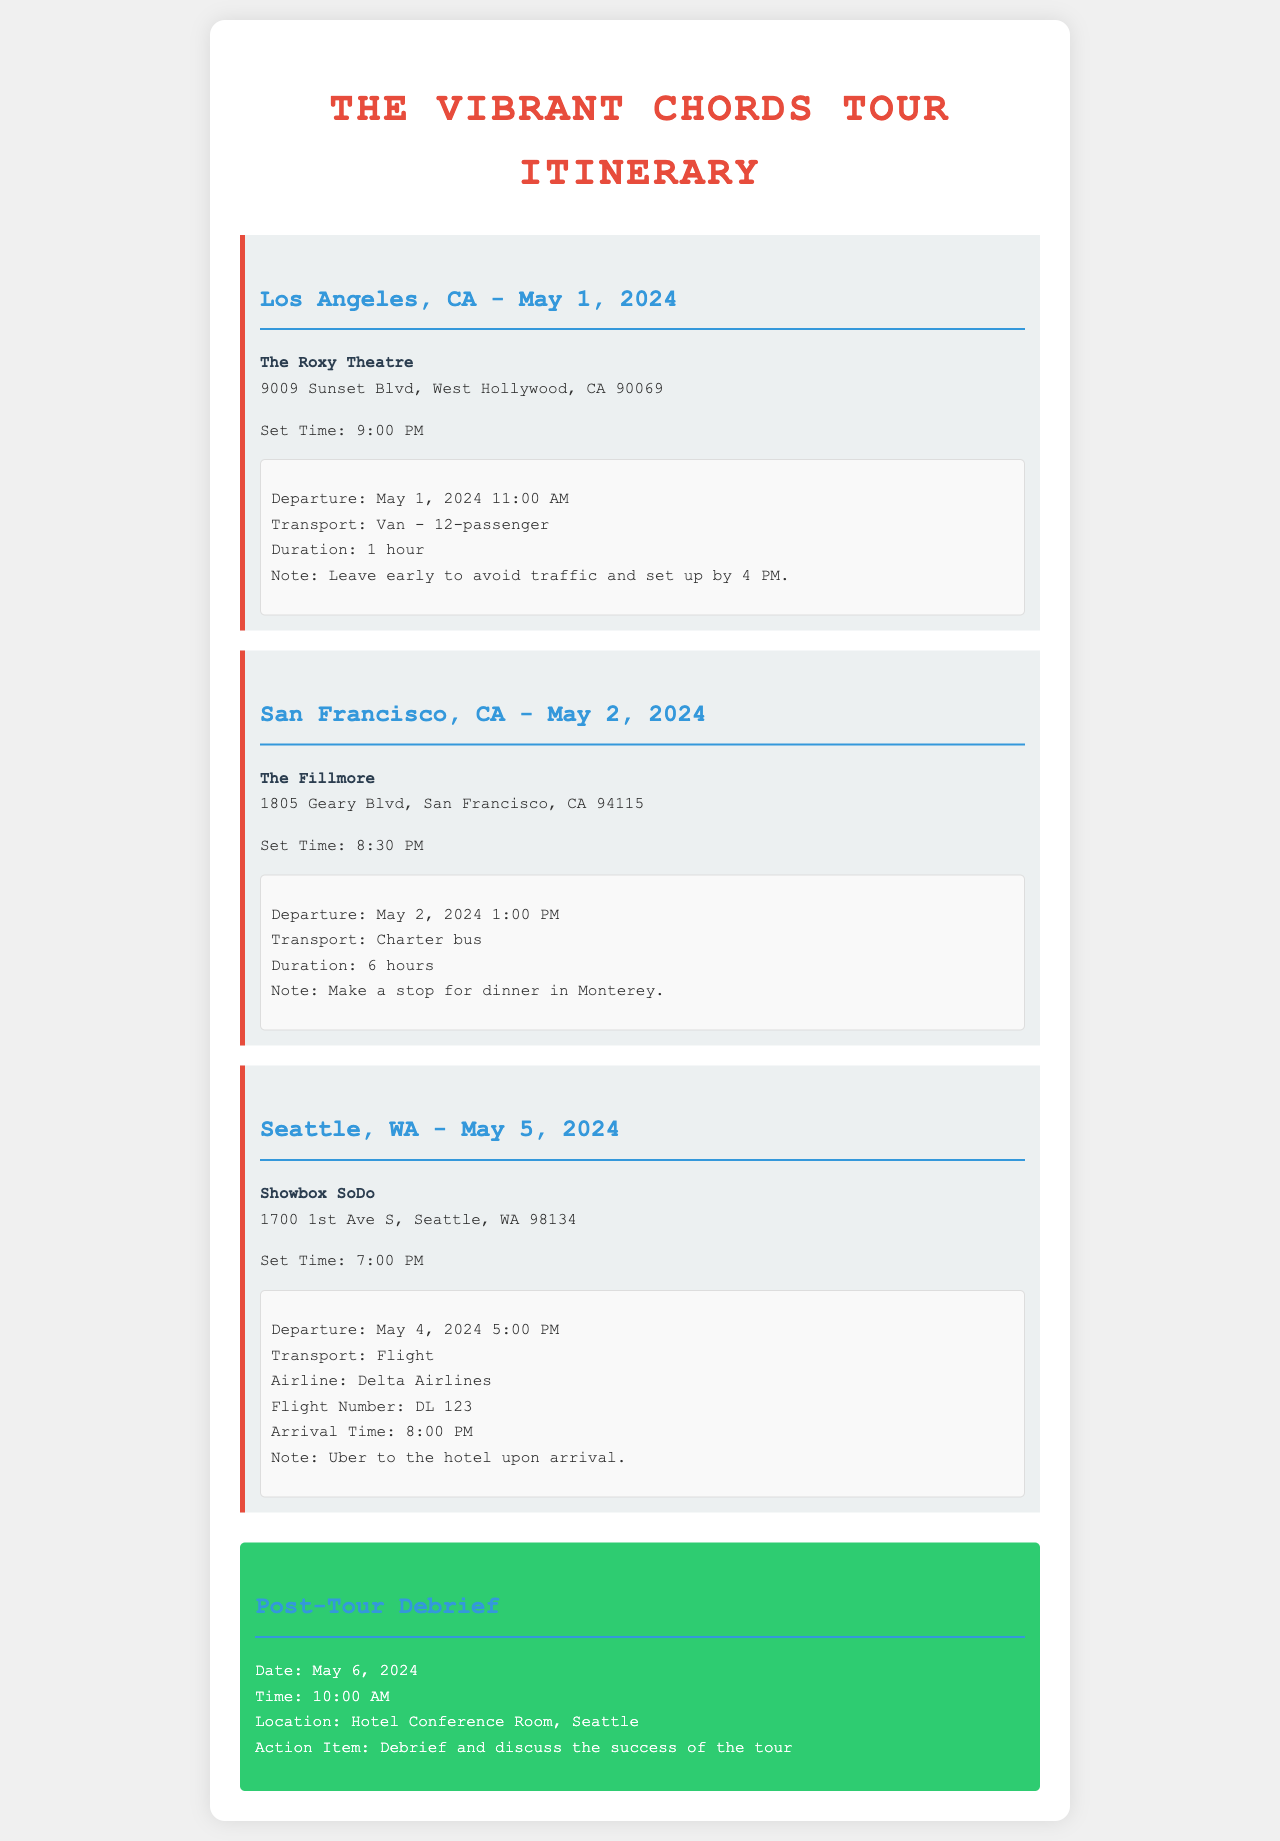what is the first venue on the tour? The first venue listed is The Roxy Theatre in Los Angeles, CA.
Answer: The Roxy Theatre what is the set time for the San Francisco show? The document states that the set time for the San Francisco show is 8:30 PM.
Answer: 8:30 PM how long is the travel duration from San Francisco to the venue? The travel duration is stated as 6 hours in the itinerary.
Answer: 6 hours what is the departure time for the Seattle flight? The departure time for the Seattle flight is mentioned as May 4, 2024, at 5:00 PM.
Answer: May 4, 2024 5:00 PM what type of transport will be used for the Los Angeles show? The itinerary specifies that a van will be used for transport to the Los Angeles show.
Answer: Van - 12-passenger how many hours is the setup before the show in Los Angeles? The document notes that the setup is to be completed by 4 PM, meaning 5 hours before the show.
Answer: 5 hours what is the post-tour debrief date? The post-tour debrief date is May 6, 2024.
Answer: May 6, 2024 which airline is used for the Seattle flight? The document mentions Delta Airlines as the airline for the Seattle flight.
Answer: Delta Airlines what is the location for the post-tour debrief meeting? The location given for the post-tour debrief is the Hotel Conference Room in Seattle.
Answer: Hotel Conference Room, Seattle 